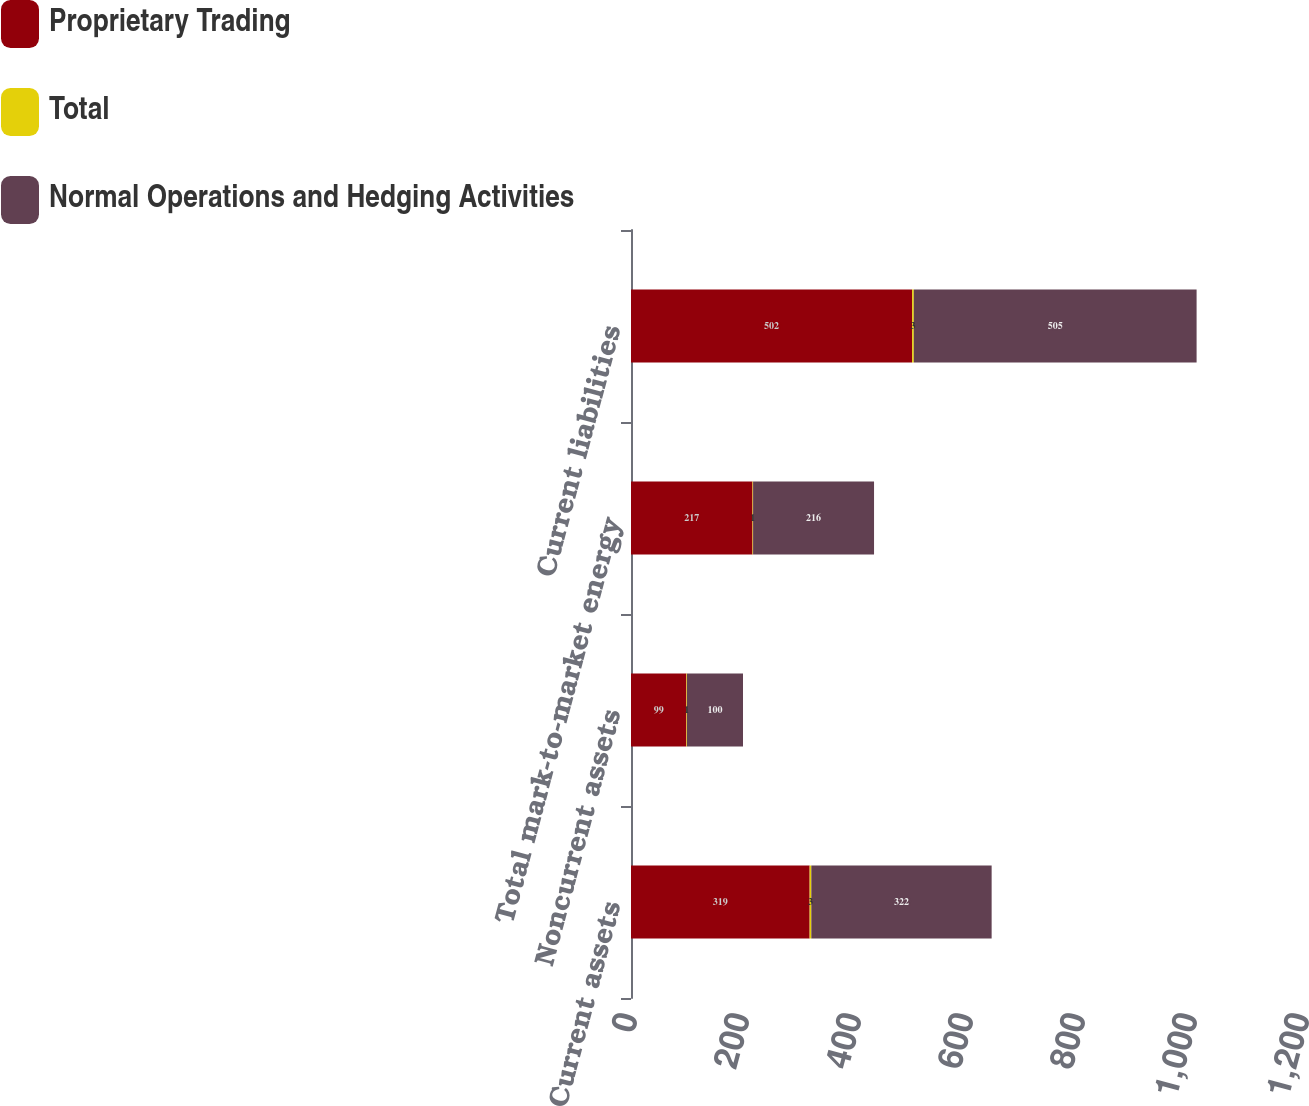Convert chart. <chart><loc_0><loc_0><loc_500><loc_500><stacked_bar_chart><ecel><fcel>Current assets<fcel>Noncurrent assets<fcel>Total mark-to-market energy<fcel>Current liabilities<nl><fcel>Proprietary Trading<fcel>319<fcel>99<fcel>217<fcel>502<nl><fcel>Total<fcel>3<fcel>1<fcel>1<fcel>3<nl><fcel>Normal Operations and Hedging Activities<fcel>322<fcel>100<fcel>216<fcel>505<nl></chart> 